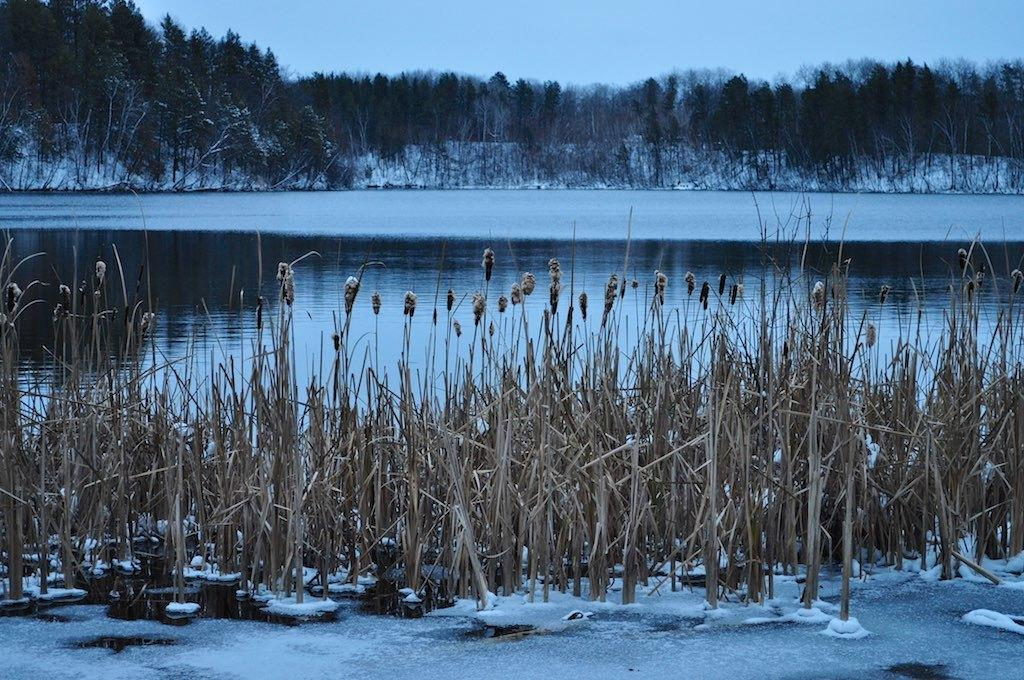What type of natural feature is present in the image? There is a river in the image. What other natural elements can be seen in the image? There are plants and trees in the image. What is the weather like in the image? There is snow visible in the image, indicating a cold climate. What type of crack can be seen in the plants in the image? There are no cracks visible in the plants in the image. 